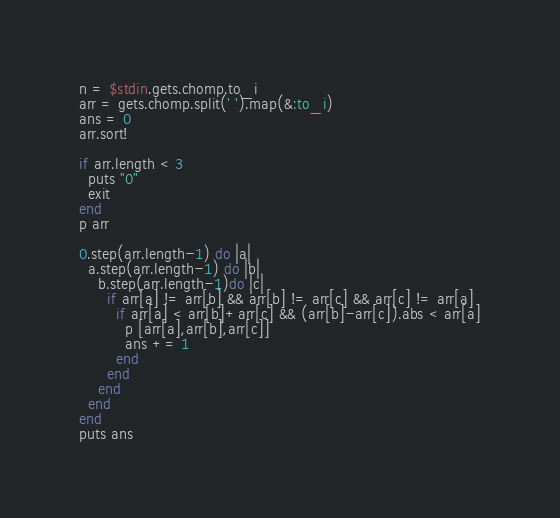Convert code to text. <code><loc_0><loc_0><loc_500><loc_500><_Ruby_>n = $stdin.gets.chomp.to_i
arr = gets.chomp.split(' ').map(&:to_i)
ans = 0
arr.sort!

if arr.length < 3
  puts "0"
  exit
end
p arr

0.step(arr.length-1) do |a|
  a.step(arr.length-1) do |b|
    b.step(arr.length-1)do |c|
      if arr[a] != arr[b] && arr[b] != arr[c] && arr[c] != arr[a]
        if arr[a] < arr[b]+arr[c] && (arr[b]-arr[c]).abs < arr[a]
          p [arr[a],arr[b],arr[c]]
          ans += 1
        end
      end
    end
  end
end
puts ans</code> 